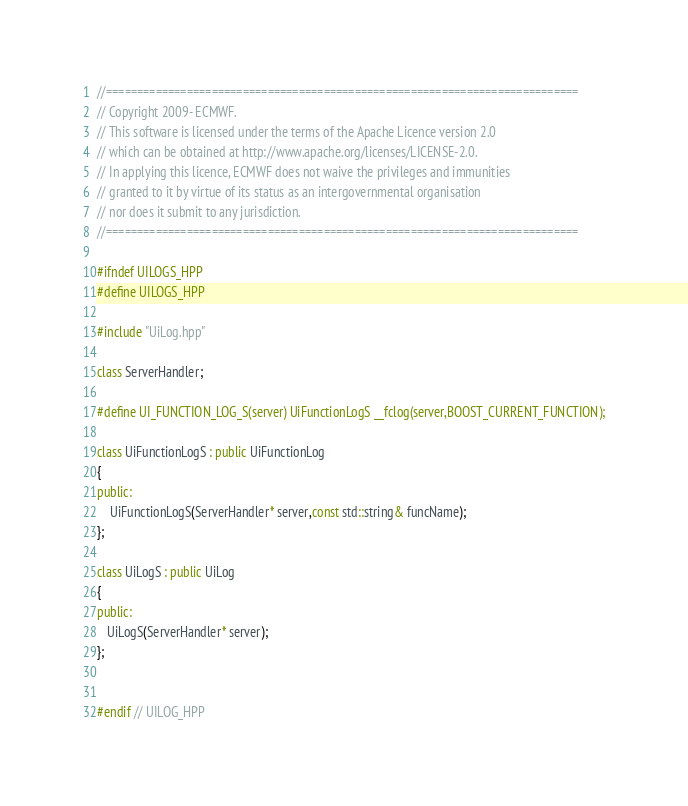<code> <loc_0><loc_0><loc_500><loc_500><_C++_>//============================================================================
// Copyright 2009- ECMWF.
// This software is licensed under the terms of the Apache Licence version 2.0
// which can be obtained at http://www.apache.org/licenses/LICENSE-2.0.
// In applying this licence, ECMWF does not waive the privileges and immunities
// granted to it by virtue of its status as an intergovernmental organisation
// nor does it submit to any jurisdiction.
//============================================================================

#ifndef UILOGS_HPP
#define UILOGS_HPP

#include "UiLog.hpp"

class ServerHandler;

#define UI_FUNCTION_LOG_S(server) UiFunctionLogS __fclog(server,BOOST_CURRENT_FUNCTION);

class UiFunctionLogS : public UiFunctionLog
{
public:
    UiFunctionLogS(ServerHandler* server,const std::string& funcName);
};

class UiLogS : public UiLog
{
public:
   UiLogS(ServerHandler* server);
};


#endif // UILOG_HPP

</code> 